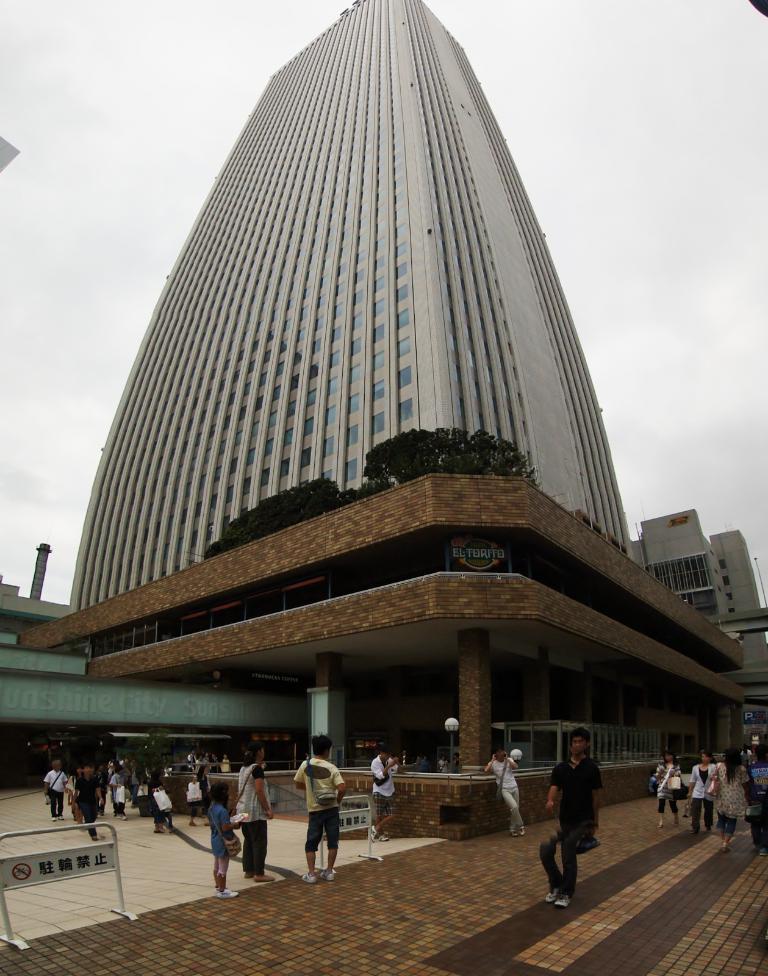How would you summarize this image in a sentence or two? At the bottom of the image there are many people. And also there is a board with some text. Behind them there is a building with glasses, walls, plants, name boards and some other things. Behind the building in the background there is sky. 